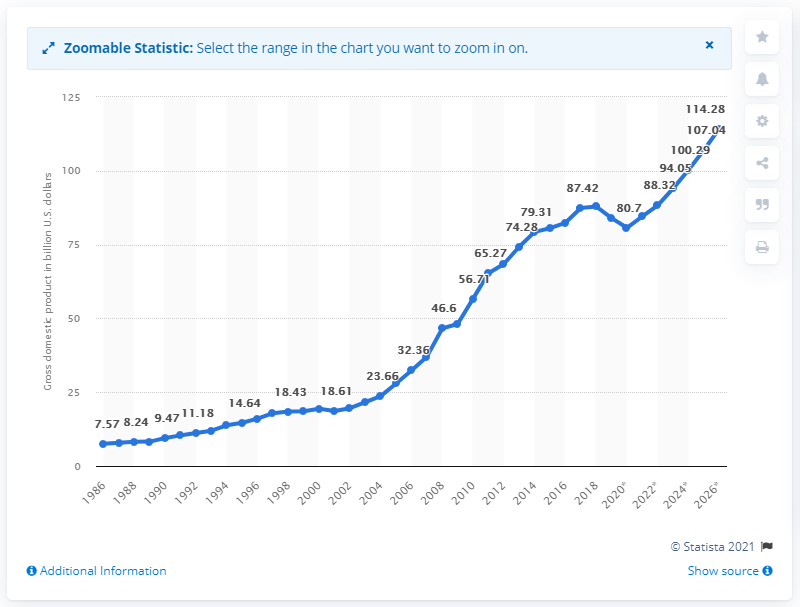Mention a couple of crucial points in this snapshot. Sri Lanka's gross domestic product in dollars in 2019 was 84.53. 